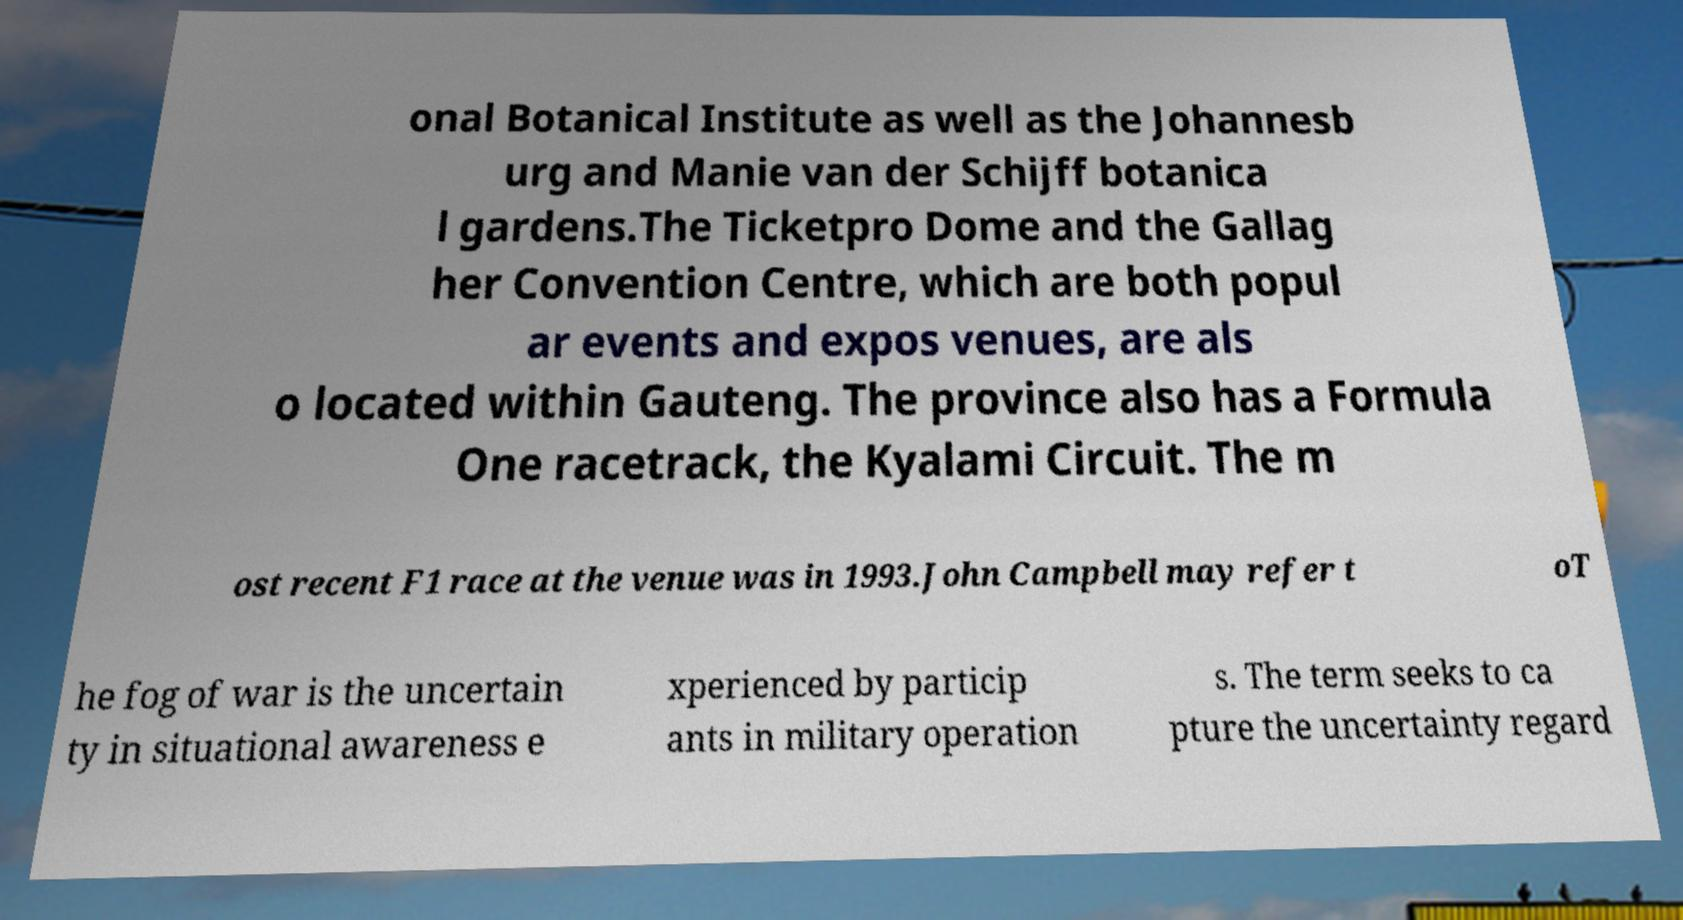Can you read and provide the text displayed in the image?This photo seems to have some interesting text. Can you extract and type it out for me? onal Botanical Institute as well as the Johannesb urg and Manie van der Schijff botanica l gardens.The Ticketpro Dome and the Gallag her Convention Centre, which are both popul ar events and expos venues, are als o located within Gauteng. The province also has a Formula One racetrack, the Kyalami Circuit. The m ost recent F1 race at the venue was in 1993.John Campbell may refer t oT he fog of war is the uncertain ty in situational awareness e xperienced by particip ants in military operation s. The term seeks to ca pture the uncertainty regard 